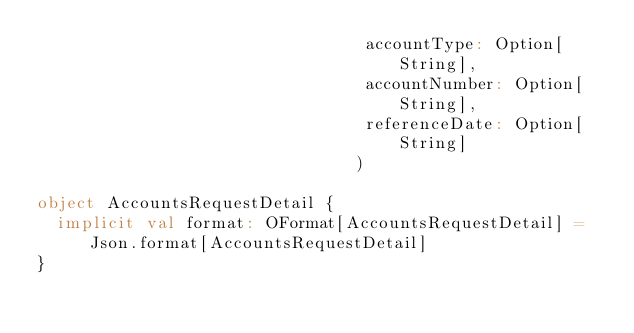Convert code to text. <code><loc_0><loc_0><loc_500><loc_500><_Scala_>                                 accountType: Option[String],
                                 accountNumber: Option[String],
                                 referenceDate: Option[String]
                                )

object AccountsRequestDetail {
  implicit val format: OFormat[AccountsRequestDetail] = Json.format[AccountsRequestDetail]
}
</code> 